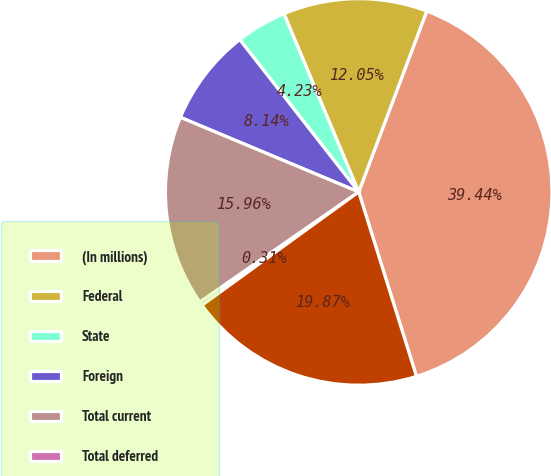Convert chart to OTSL. <chart><loc_0><loc_0><loc_500><loc_500><pie_chart><fcel>(In millions)<fcel>Federal<fcel>State<fcel>Foreign<fcel>Total current<fcel>Total deferred<fcel>Income tax expense<nl><fcel>39.44%<fcel>12.05%<fcel>4.23%<fcel>8.14%<fcel>15.96%<fcel>0.31%<fcel>19.87%<nl></chart> 